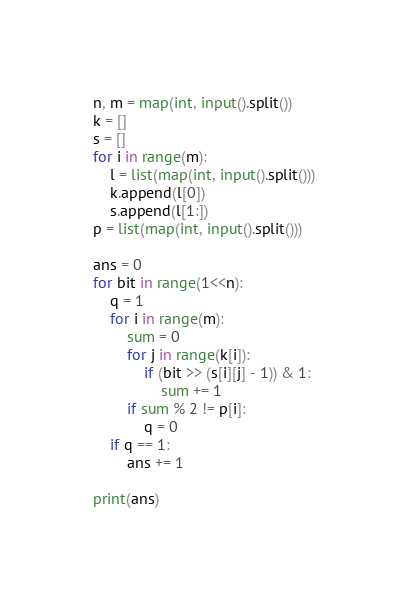<code> <loc_0><loc_0><loc_500><loc_500><_Python_>n, m = map(int, input().split())
k = []
s = []
for i in range(m):
    l = list(map(int, input().split()))
    k.append(l[0])
    s.append(l[1:])
p = list(map(int, input().split()))

ans = 0
for bit in range(1<<n):
    q = 1
    for i in range(m):
        sum = 0
        for j in range(k[i]):
            if (bit >> (s[i][j] - 1)) & 1:
                sum += 1
        if sum % 2 != p[i]:
            q = 0
    if q == 1:
        ans += 1

print(ans)</code> 